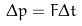Convert formula to latex. <formula><loc_0><loc_0><loc_500><loc_500>\Delta p = F \Delta t</formula> 